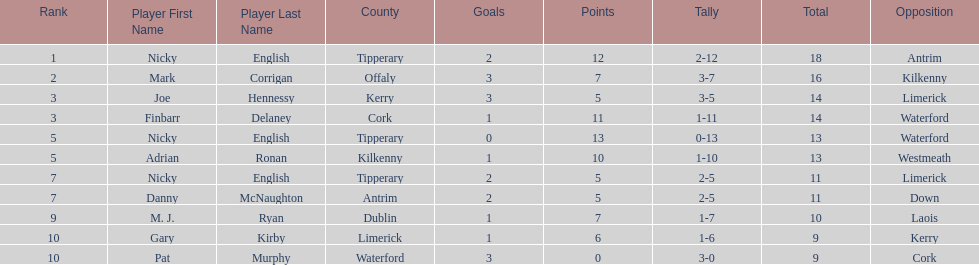Who ranked above mark corrigan? Nicky English. 